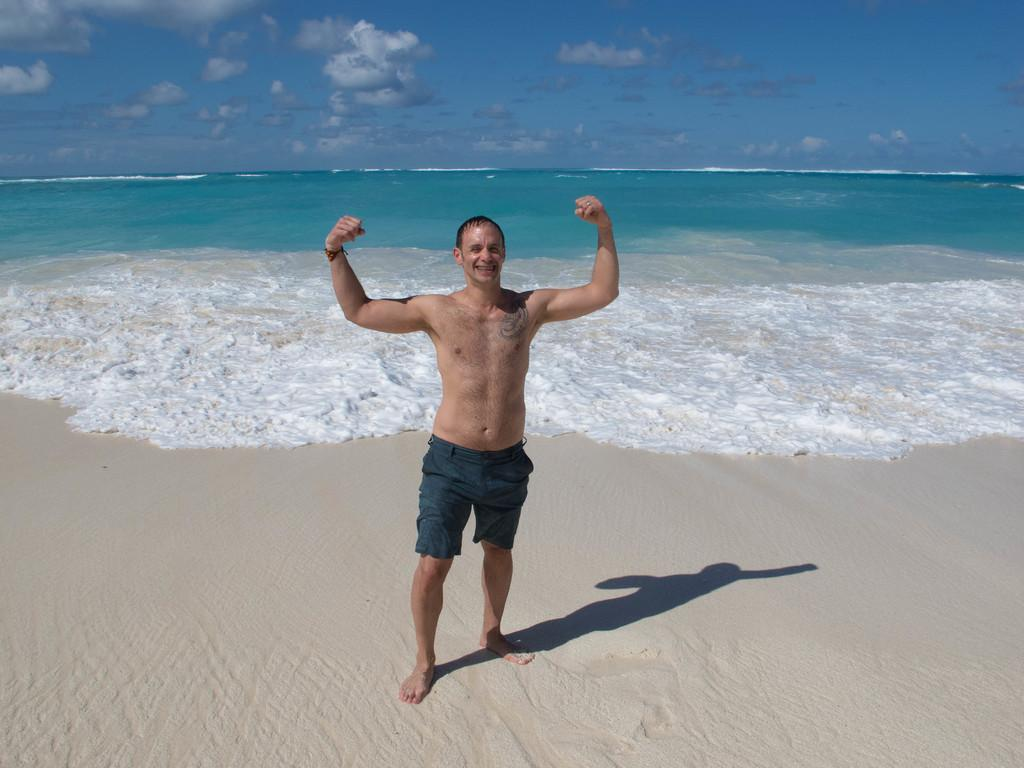What is the main subject of the image? There is a man standing in the center of the image. What is the man's facial expression? The man is smiling. What can be seen in the background of the image? There is a sea in the background of the image. What is visible at the bottom of the image? A seashore is visible at the bottom of the image. What is visible at the top of the image? The sky is visible at the top of the image. What type of furniture is visible in the image? There is no furniture present in the image. What is the man sitting on in the image? The man is standing, not sitting, in the image. 